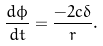<formula> <loc_0><loc_0><loc_500><loc_500>\frac { d \phi } { d t } = \frac { - 2 c \delta } { r } .</formula> 